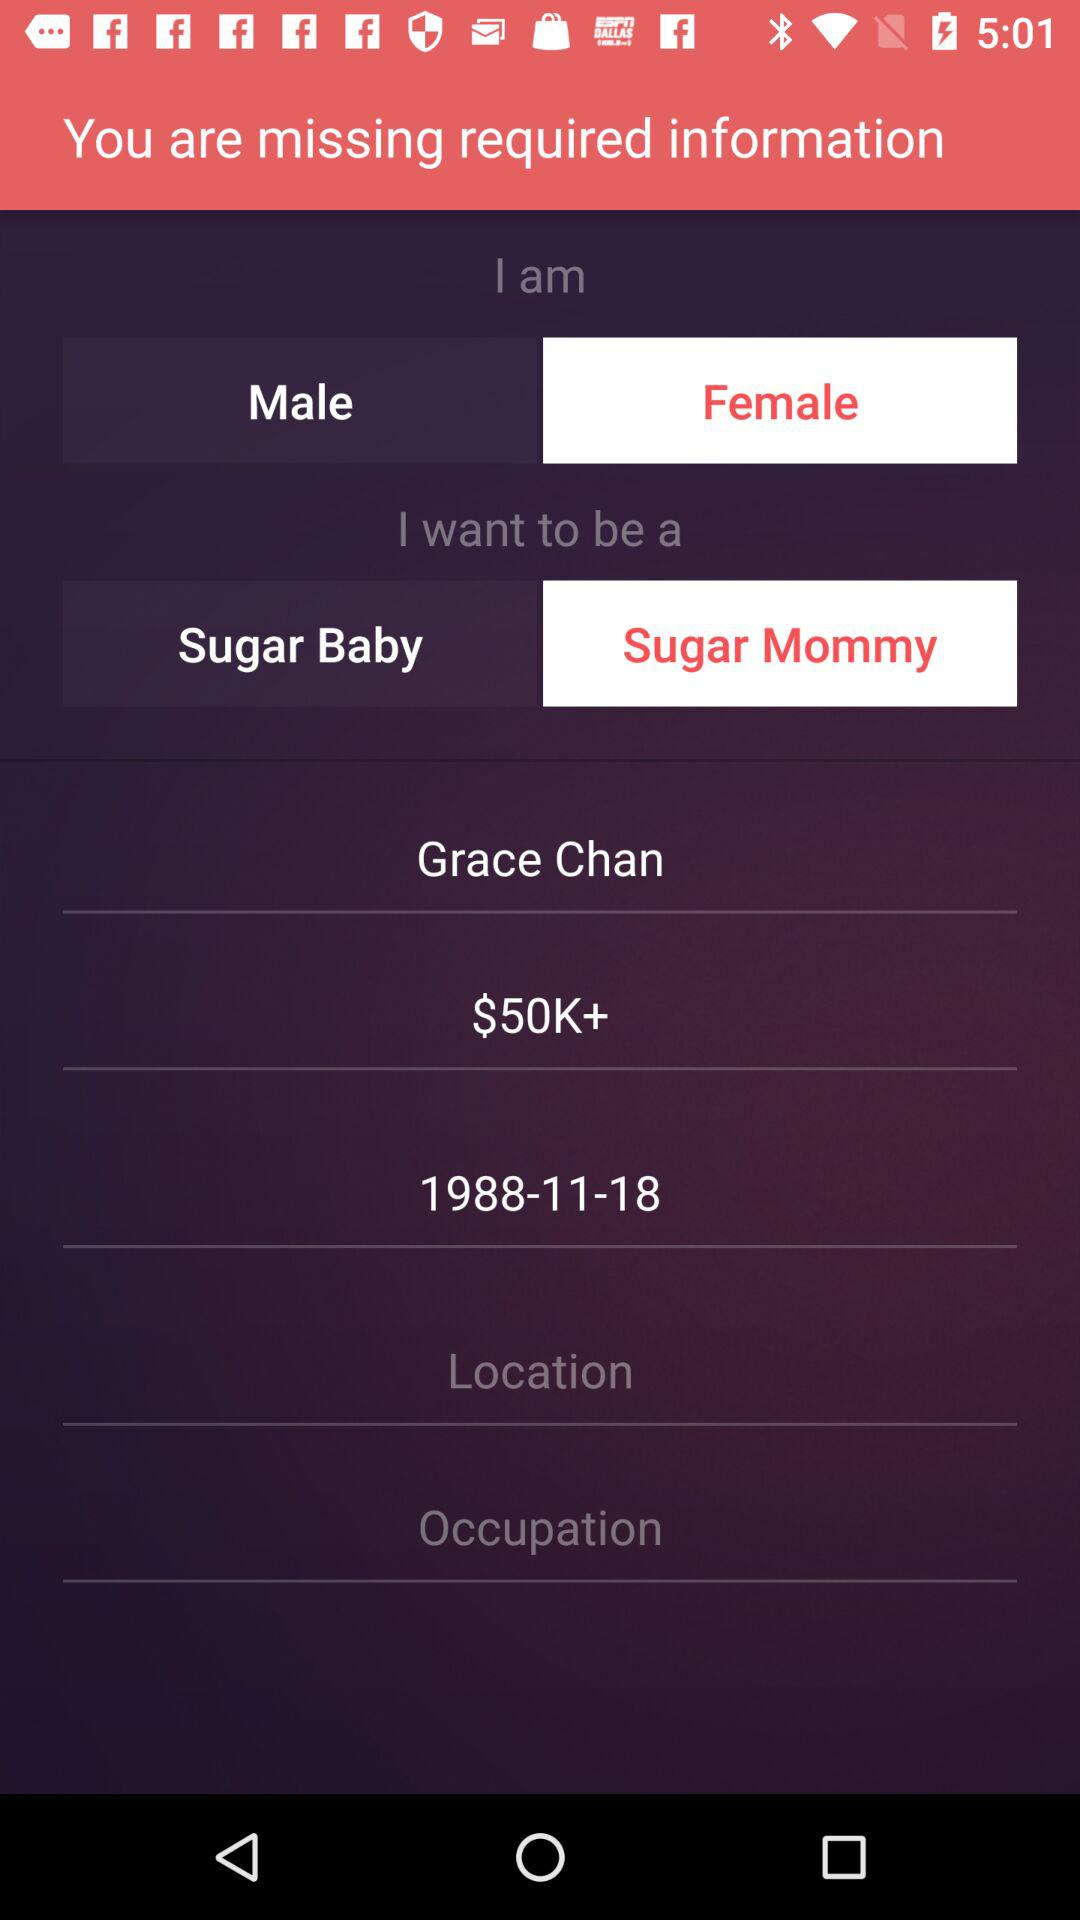What is the gender of a user? The gender is "Female". 